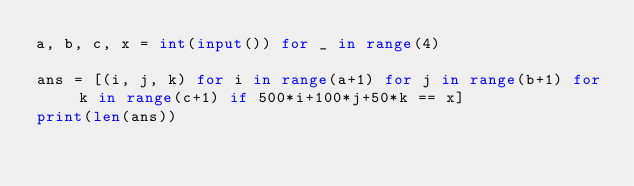Convert code to text. <code><loc_0><loc_0><loc_500><loc_500><_Python_>a, b, c, x = int(input()) for _ in range(4) 

ans = [(i, j, k) for i in range(a+1) for j in range(b+1) for k in range(c+1) if 500*i+100*j+50*k == x]
print(len(ans))
</code> 